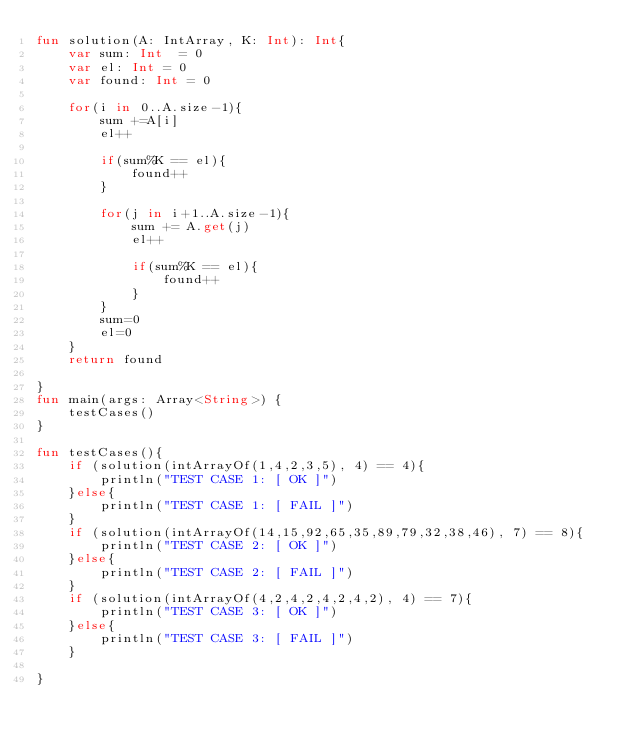Convert code to text. <code><loc_0><loc_0><loc_500><loc_500><_Kotlin_>fun solution(A: IntArray, K: Int): Int{
    var sum: Int  = 0
    var el: Int = 0
    var found: Int = 0

    for(i in 0..A.size-1){
        sum +=A[i]
        el++

        if(sum%K == el){
            found++
        }

        for(j in i+1..A.size-1){
            sum += A.get(j)
            el++

            if(sum%K == el){
                found++
            }
        }
        sum=0
        el=0
    }
    return found

}
fun main(args: Array<String>) {
    testCases()
}

fun testCases(){
    if (solution(intArrayOf(1,4,2,3,5), 4) == 4){
        println("TEST CASE 1: [ OK ]")
    }else{
        println("TEST CASE 1: [ FAIL ]")
    }
    if (solution(intArrayOf(14,15,92,65,35,89,79,32,38,46), 7) == 8){
        println("TEST CASE 2: [ OK ]")
    }else{
        println("TEST CASE 2: [ FAIL ]")
    }
    if (solution(intArrayOf(4,2,4,2,4,2,4,2), 4) == 7){
        println("TEST CASE 3: [ OK ]")
    }else{
        println("TEST CASE 3: [ FAIL ]")
    }

}</code> 